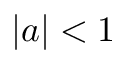Convert formula to latex. <formula><loc_0><loc_0><loc_500><loc_500>| a | < 1</formula> 